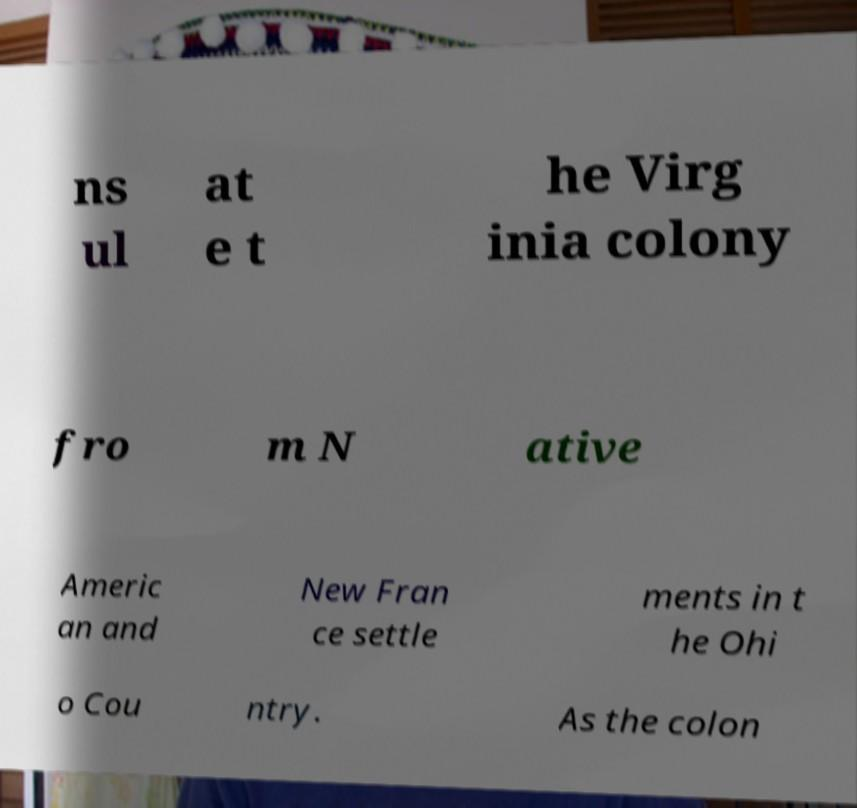For documentation purposes, I need the text within this image transcribed. Could you provide that? ns ul at e t he Virg inia colony fro m N ative Americ an and New Fran ce settle ments in t he Ohi o Cou ntry. As the colon 